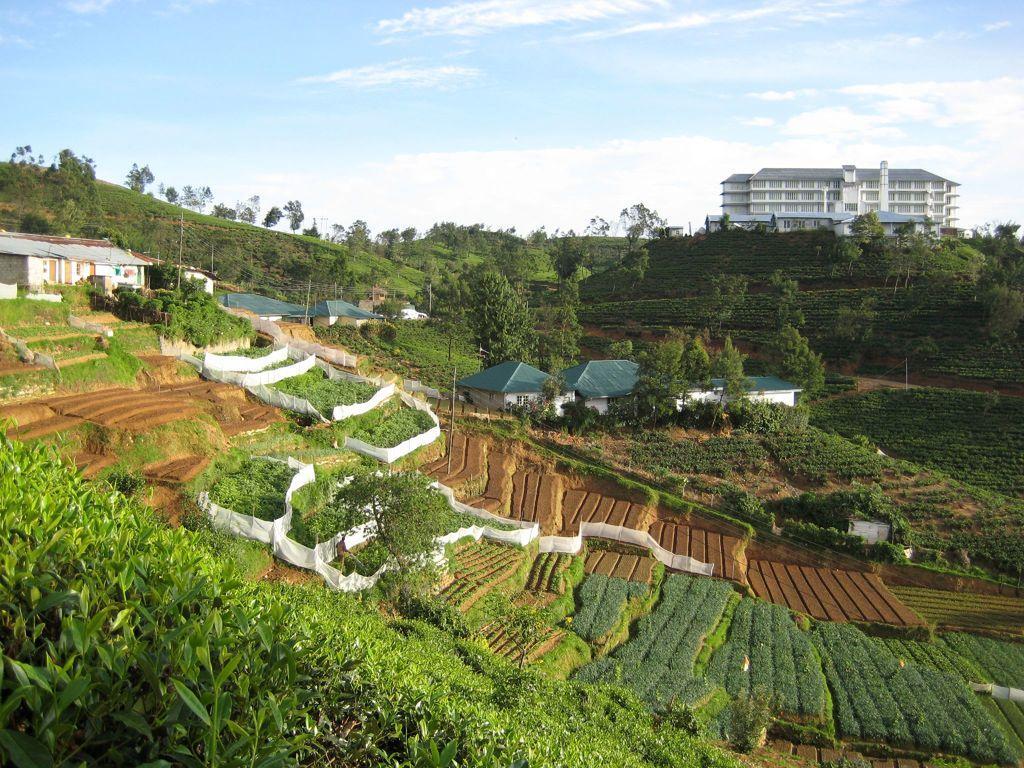Please provide a concise description of this image. In this at the bottom there are some plants grass, and in the center there are some stairs. And in the background there are some buildings and trees and some mountains, and at the top of the image there is sky. 